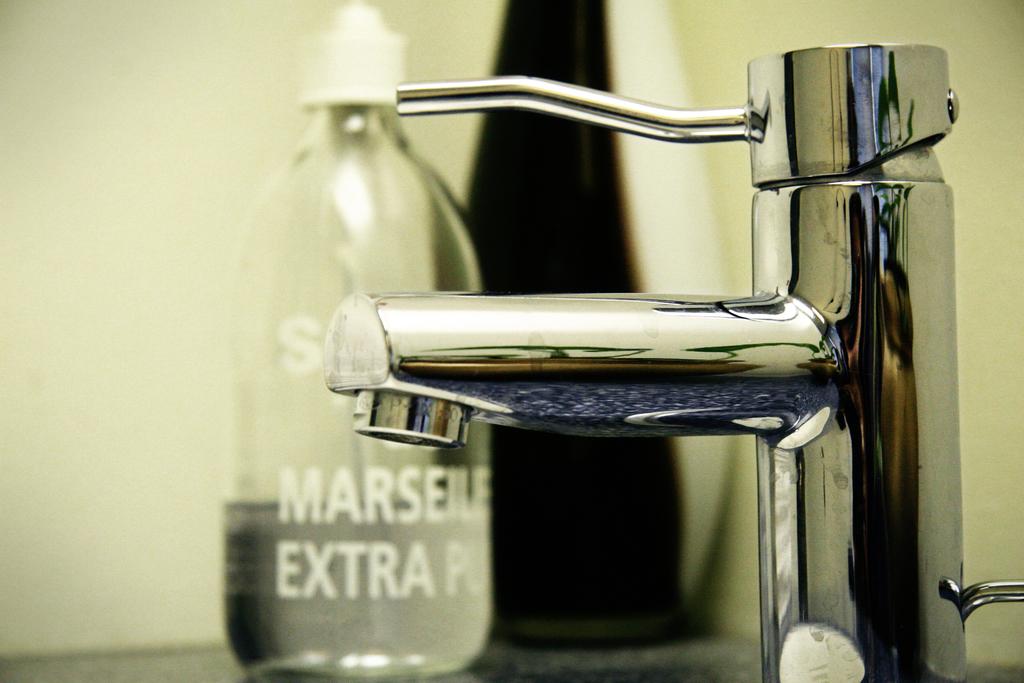Does this remind you of breaking bad?
Your response must be concise. No. What brand is it?
Provide a short and direct response. Unanswerable. 